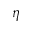Convert formula to latex. <formula><loc_0><loc_0><loc_500><loc_500>\eta</formula> 